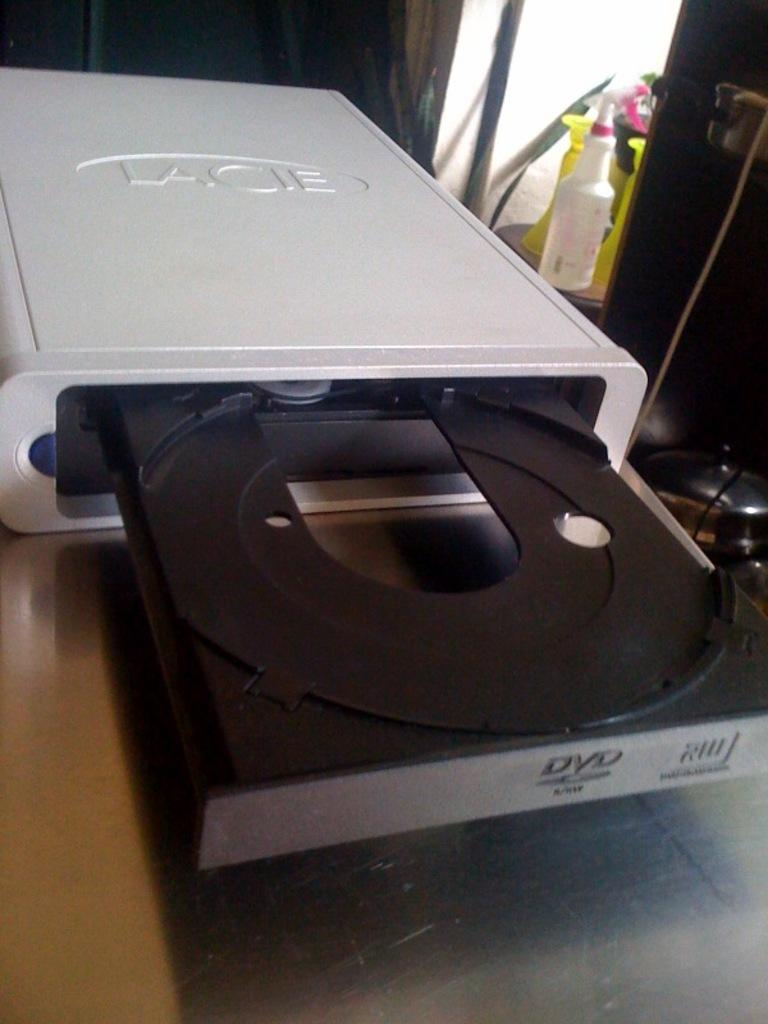<image>
Provide a brief description of the given image. A silver Lacie brand DVD player is opened. 